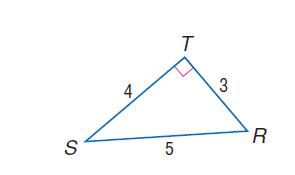Answer the mathemtical geometry problem and directly provide the correct option letter.
Question: find \tan R.
Choices: A: \frac { 3 } { 5 } B: \frac { 3 } { 4 } C: \frac { 4 } { 5 } D: \frac { 4 } { 3 } D 